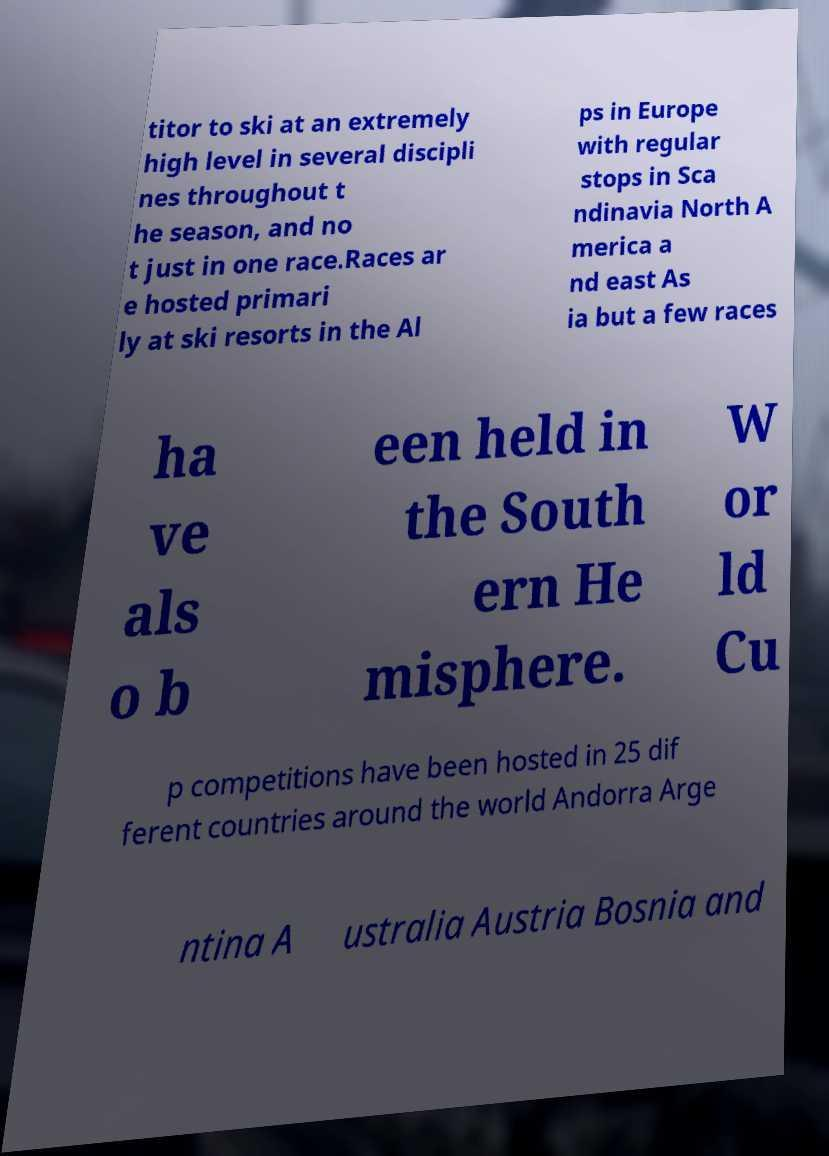Could you assist in decoding the text presented in this image and type it out clearly? titor to ski at an extremely high level in several discipli nes throughout t he season, and no t just in one race.Races ar e hosted primari ly at ski resorts in the Al ps in Europe with regular stops in Sca ndinavia North A merica a nd east As ia but a few races ha ve als o b een held in the South ern He misphere. W or ld Cu p competitions have been hosted in 25 dif ferent countries around the world Andorra Arge ntina A ustralia Austria Bosnia and 